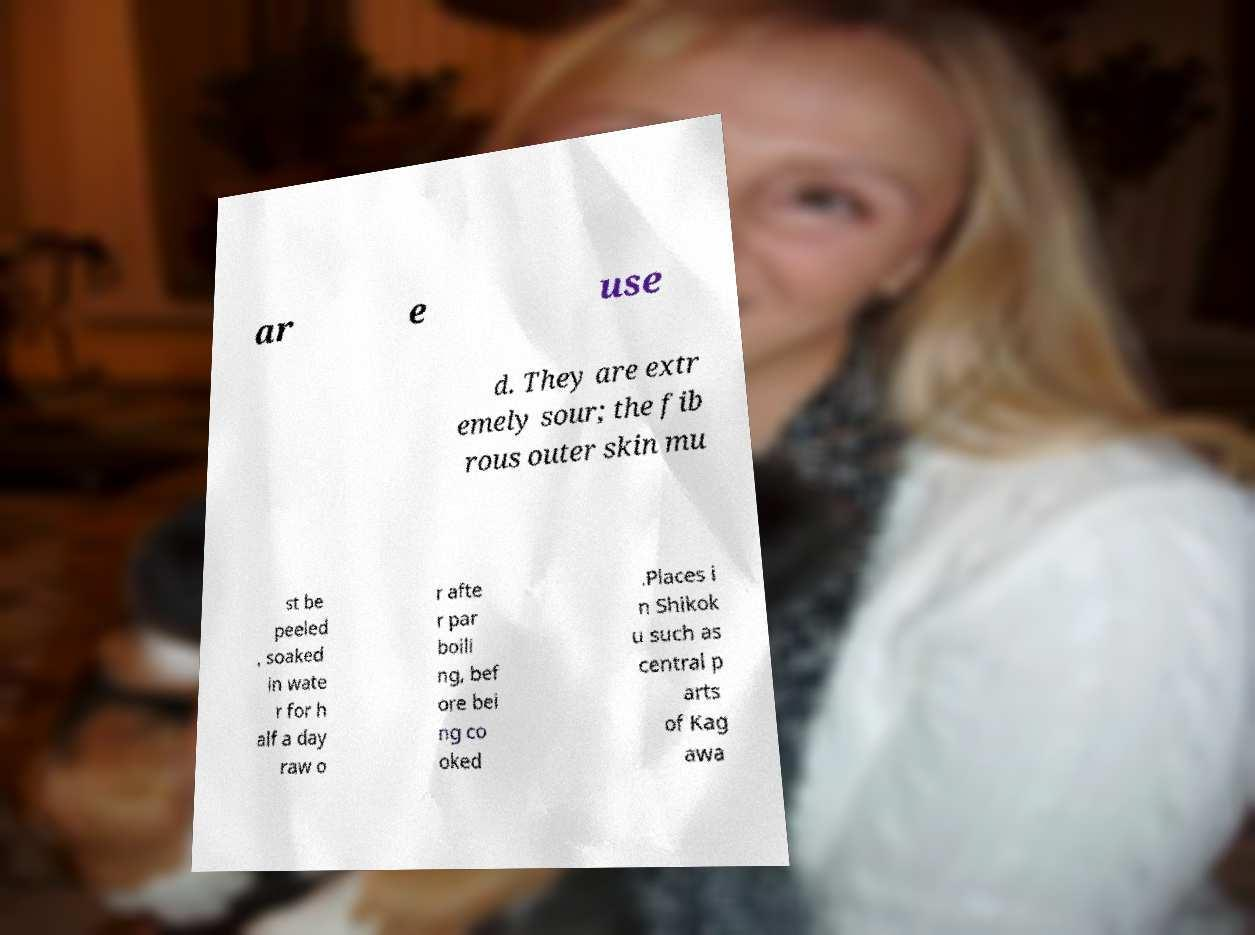Please identify and transcribe the text found in this image. ar e use d. They are extr emely sour; the fib rous outer skin mu st be peeled , soaked in wate r for h alf a day raw o r afte r par boili ng, bef ore bei ng co oked .Places i n Shikok u such as central p arts of Kag awa 